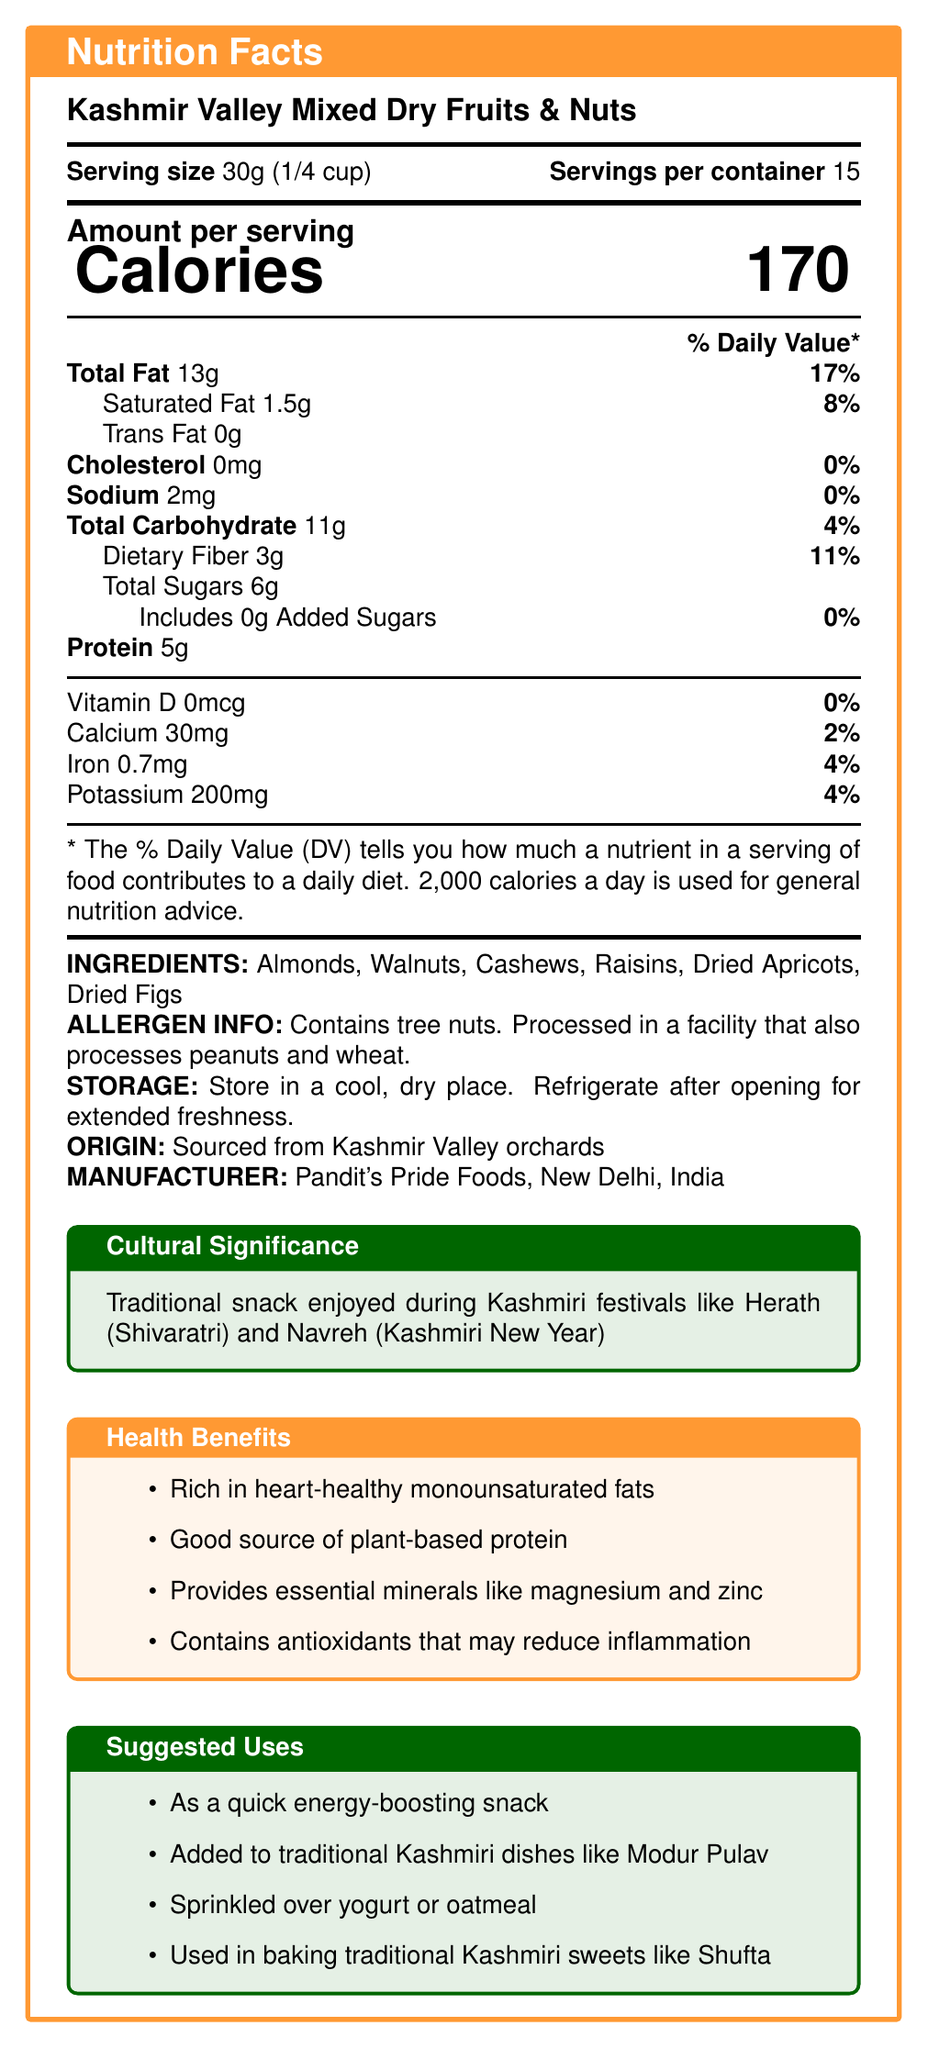what is the serving size? The serving size section specifies it as 30g or 1/4 cup.
Answer: 30g (1/4 cup) how many servings are in the container? The document states there are 15 servings per container.
Answer: 15 how many calories are in one serving? The Calories section shows 170 calories per serving.
Answer: 170 what is the percentage of daily value for total fat per serving? The Total Fat section states that one serving provides 17% of the daily value.
Answer: 17% what is the sodium content in one serving? The Sodium section lists the sodium content as 2mg per serving.
Answer: 2mg what are the main ingredients? The Ingredients section lists these items.
Answer: Almonds, Walnuts, Cashews, Raisins, Dried Apricots, Dried Figs how should the product be stored after opening? The Storage Instructions section advises to refrigerate after opening for extended freshness.
Answer: Refrigerate after opening for extended freshness which nutrient has the highest daily value percentage? A) Total Fat B) Sodium C) Dietary Fiber Total Fat has the highest daily value percentage at 17%, compared to 0% for Sodium and 11% for Dietary Fiber.
Answer: A) Total Fat which allergen is specifically listed in the document? A) Gluten B) Dairy C) Tree Nuts D) Soy The Allergen Info section states that the product contains tree nuts.
Answer: C) Tree Nuts is this product processed in a facility that also processes wheat? The Allergen Info section confirms processing in a facility that also processes wheat.
Answer: Yes does this product contain any added sugars? The Total Sugars section states that it includes 0g of Added Sugars.
Answer: No what traditional Kashmiri dish is recommended to add this product to? The Suggested Uses section recommends adding it to Modur Pulav.
Answer: Modur Pulav cannot be determined based on the document The document does not provide detailed proportions of each ingredient.
Answer: What is the exact percentage of almonds in the mixture? what is the health benefit of the product's antioxidants? The Health Benefits section states that the antioxidants may reduce inflammation.
Answer: May reduce inflammation how much potassium is in one serving? The Potassium section lists it as 200mg per serving.
Answer: 200mg describe the entire document or the main idea The document provides comprehensive information about a product, including its nutritional facts, ingredients, storage and allergen information, and cultural relevance, along with its health benefits and various suggested uses.
Answer: The document is a nutrition label for "Kashmir Valley Mixed Dry Fruits & Nuts," detailing serving size, nutritional content, ingredients, allergen information, storage instructions, origin, manufacturer, cultural significance, health benefits, and suggested uses. 